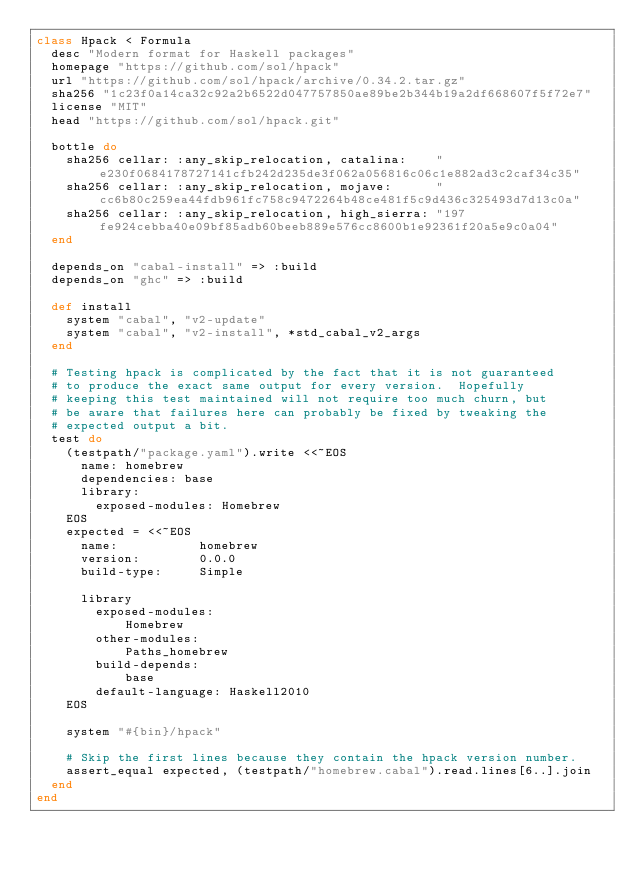Convert code to text. <code><loc_0><loc_0><loc_500><loc_500><_Ruby_>class Hpack < Formula
  desc "Modern format for Haskell packages"
  homepage "https://github.com/sol/hpack"
  url "https://github.com/sol/hpack/archive/0.34.2.tar.gz"
  sha256 "1c23f0a14ca32c92a2b6522d047757850ae89be2b344b19a2df668607f5f72e7"
  license "MIT"
  head "https://github.com/sol/hpack.git"

  bottle do
    sha256 cellar: :any_skip_relocation, catalina:    "e230f0684178727141cfb242d235de3f062a056816c06c1e882ad3c2caf34c35"
    sha256 cellar: :any_skip_relocation, mojave:      "cc6b80c259ea44fdb961fc758c9472264b48ce481f5c9d436c325493d7d13c0a"
    sha256 cellar: :any_skip_relocation, high_sierra: "197fe924cebba40e09bf85adb60beeb889e576cc8600b1e92361f20a5e9c0a04"
  end

  depends_on "cabal-install" => :build
  depends_on "ghc" => :build

  def install
    system "cabal", "v2-update"
    system "cabal", "v2-install", *std_cabal_v2_args
  end

  # Testing hpack is complicated by the fact that it is not guaranteed
  # to produce the exact same output for every version.  Hopefully
  # keeping this test maintained will not require too much churn, but
  # be aware that failures here can probably be fixed by tweaking the
  # expected output a bit.
  test do
    (testpath/"package.yaml").write <<~EOS
      name: homebrew
      dependencies: base
      library:
        exposed-modules: Homebrew
    EOS
    expected = <<~EOS
      name:           homebrew
      version:        0.0.0
      build-type:     Simple

      library
        exposed-modules:
            Homebrew
        other-modules:
            Paths_homebrew
        build-depends:
            base
        default-language: Haskell2010
    EOS

    system "#{bin}/hpack"

    # Skip the first lines because they contain the hpack version number.
    assert_equal expected, (testpath/"homebrew.cabal").read.lines[6..].join
  end
end
</code> 